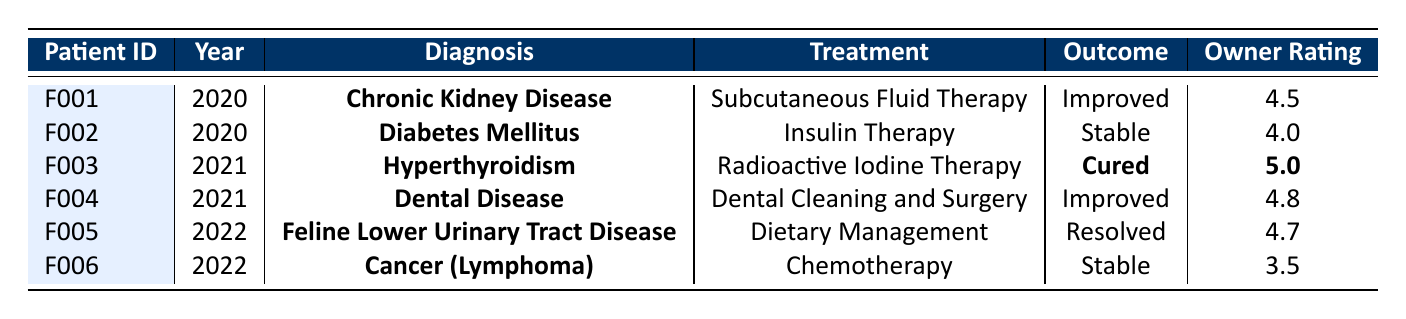What is the outcome for feline patient F003? In the table, the entry for feline patient F003 indicates an outcome of "Cured".
Answer: Cured How many months was the treatment duration for the feline patient with Diabetes Mellitus? The table shows that the treatment duration for the feline patient diagnosed with Diabetes Mellitus (F002) is 12 months.
Answer: 12 months Which treatment had the highest owner satisfaction rating? The highest owner satisfaction rating is 5.0, associated with the treatment "Radioactive Iodine Therapy" for the diagnosis of Hyperthyroidism (F003).
Answer: 5.0 What was the total treatment duration for all patients combined in 2022? For 2022, the treatment durations are 4 months (F005) and 8 months (F006). Adding these gives 4 + 8 = 12 months in total.
Answer: 12 months Was "Improved" the outcome for any patient in 2021? Yes, the patient with the diagnosis of Dental Disease (F004) had an outcome of "Improved" in 2021.
Answer: Yes Which diagnosis had an outcome of "Resolved"? The table indicates that the diagnosis with an outcome of "Resolved" is "Feline Lower Urinary Tract Disease" for patient F005.
Answer: Feline Lower Urinary Tract Disease What is the average owner satisfaction rating across all treatments in 2021? The owner satisfaction ratings for 2021 are 5.0 (F003) and 4.8 (F004). The average is (5.0 + 4.8) / 2 = 4.9.
Answer: 4.9 How many patients were diagnosed with Cancer? There is one patient, F006, who has been diagnosed with Cancer (Lymphoma) according to the table.
Answer: 1 patient Which treatment had the lowest owner satisfaction rating? The treatment with the lowest owner satisfaction rating is "Chemotherapy" with a rating of 3.5 for patient F006.
Answer: 3.5 Did any treatment result in the outcome of "Stable"? Yes, there were two instances of "Stable" outcomes for the treatments of Insulin Therapy (F002) and Chemotherapy (F006).
Answer: Yes 